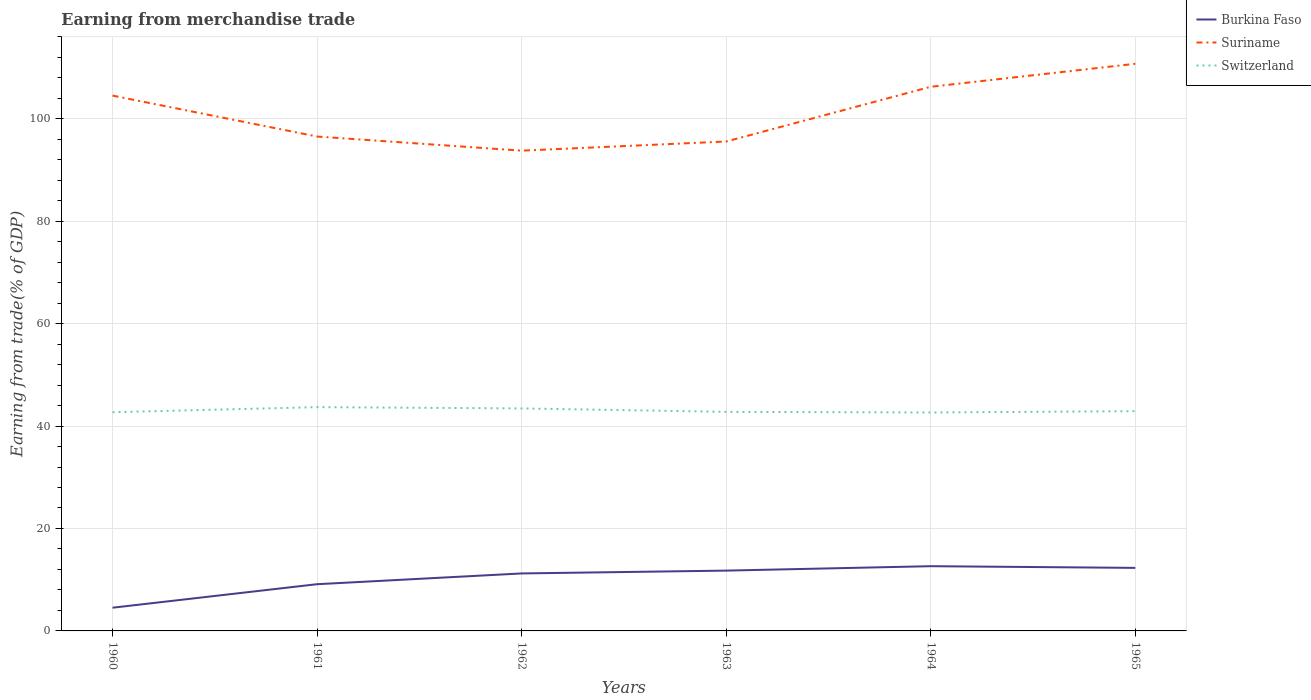Does the line corresponding to Switzerland intersect with the line corresponding to Burkina Faso?
Your response must be concise. No. Is the number of lines equal to the number of legend labels?
Your response must be concise. Yes. Across all years, what is the maximum earnings from trade in Burkina Faso?
Provide a succinct answer. 4.53. What is the total earnings from trade in Suriname in the graph?
Give a very brief answer. 8.96. What is the difference between the highest and the second highest earnings from trade in Suriname?
Ensure brevity in your answer.  16.96. What is the difference between the highest and the lowest earnings from trade in Switzerland?
Provide a succinct answer. 2. Is the earnings from trade in Switzerland strictly greater than the earnings from trade in Suriname over the years?
Your response must be concise. Yes. How many years are there in the graph?
Provide a short and direct response. 6. Does the graph contain any zero values?
Ensure brevity in your answer.  No. Does the graph contain grids?
Offer a terse response. Yes. Where does the legend appear in the graph?
Ensure brevity in your answer.  Top right. What is the title of the graph?
Provide a short and direct response. Earning from merchandise trade. Does "Morocco" appear as one of the legend labels in the graph?
Keep it short and to the point. No. What is the label or title of the X-axis?
Offer a very short reply. Years. What is the label or title of the Y-axis?
Offer a very short reply. Earning from trade(% of GDP). What is the Earning from trade(% of GDP) of Burkina Faso in 1960?
Give a very brief answer. 4.53. What is the Earning from trade(% of GDP) of Suriname in 1960?
Keep it short and to the point. 104.5. What is the Earning from trade(% of GDP) of Switzerland in 1960?
Give a very brief answer. 42.69. What is the Earning from trade(% of GDP) in Burkina Faso in 1961?
Your response must be concise. 9.12. What is the Earning from trade(% of GDP) of Suriname in 1961?
Offer a terse response. 96.51. What is the Earning from trade(% of GDP) of Switzerland in 1961?
Your response must be concise. 43.69. What is the Earning from trade(% of GDP) of Burkina Faso in 1962?
Provide a succinct answer. 11.22. What is the Earning from trade(% of GDP) of Suriname in 1962?
Provide a short and direct response. 93.76. What is the Earning from trade(% of GDP) of Switzerland in 1962?
Your answer should be compact. 43.44. What is the Earning from trade(% of GDP) of Burkina Faso in 1963?
Make the answer very short. 11.77. What is the Earning from trade(% of GDP) of Suriname in 1963?
Offer a terse response. 95.54. What is the Earning from trade(% of GDP) in Switzerland in 1963?
Ensure brevity in your answer.  42.77. What is the Earning from trade(% of GDP) in Burkina Faso in 1964?
Your answer should be compact. 12.64. What is the Earning from trade(% of GDP) of Suriname in 1964?
Offer a very short reply. 106.23. What is the Earning from trade(% of GDP) of Switzerland in 1964?
Ensure brevity in your answer.  42.64. What is the Earning from trade(% of GDP) of Burkina Faso in 1965?
Your response must be concise. 12.31. What is the Earning from trade(% of GDP) of Suriname in 1965?
Keep it short and to the point. 110.72. What is the Earning from trade(% of GDP) in Switzerland in 1965?
Your response must be concise. 42.9. Across all years, what is the maximum Earning from trade(% of GDP) of Burkina Faso?
Provide a short and direct response. 12.64. Across all years, what is the maximum Earning from trade(% of GDP) of Suriname?
Offer a very short reply. 110.72. Across all years, what is the maximum Earning from trade(% of GDP) of Switzerland?
Offer a terse response. 43.69. Across all years, what is the minimum Earning from trade(% of GDP) in Burkina Faso?
Offer a terse response. 4.53. Across all years, what is the minimum Earning from trade(% of GDP) in Suriname?
Your response must be concise. 93.76. Across all years, what is the minimum Earning from trade(% of GDP) of Switzerland?
Your response must be concise. 42.64. What is the total Earning from trade(% of GDP) in Burkina Faso in the graph?
Provide a succinct answer. 61.59. What is the total Earning from trade(% of GDP) in Suriname in the graph?
Offer a very short reply. 607.27. What is the total Earning from trade(% of GDP) in Switzerland in the graph?
Your response must be concise. 258.13. What is the difference between the Earning from trade(% of GDP) in Burkina Faso in 1960 and that in 1961?
Offer a terse response. -4.59. What is the difference between the Earning from trade(% of GDP) of Suriname in 1960 and that in 1961?
Provide a short and direct response. 7.99. What is the difference between the Earning from trade(% of GDP) of Switzerland in 1960 and that in 1961?
Provide a succinct answer. -0.99. What is the difference between the Earning from trade(% of GDP) of Burkina Faso in 1960 and that in 1962?
Make the answer very short. -6.69. What is the difference between the Earning from trade(% of GDP) of Suriname in 1960 and that in 1962?
Keep it short and to the point. 10.75. What is the difference between the Earning from trade(% of GDP) in Switzerland in 1960 and that in 1962?
Offer a very short reply. -0.74. What is the difference between the Earning from trade(% of GDP) of Burkina Faso in 1960 and that in 1963?
Your response must be concise. -7.24. What is the difference between the Earning from trade(% of GDP) in Suriname in 1960 and that in 1963?
Give a very brief answer. 8.96. What is the difference between the Earning from trade(% of GDP) of Switzerland in 1960 and that in 1963?
Your response must be concise. -0.07. What is the difference between the Earning from trade(% of GDP) of Burkina Faso in 1960 and that in 1964?
Your response must be concise. -8.1. What is the difference between the Earning from trade(% of GDP) in Suriname in 1960 and that in 1964?
Provide a succinct answer. -1.72. What is the difference between the Earning from trade(% of GDP) of Switzerland in 1960 and that in 1964?
Keep it short and to the point. 0.05. What is the difference between the Earning from trade(% of GDP) in Burkina Faso in 1960 and that in 1965?
Make the answer very short. -7.78. What is the difference between the Earning from trade(% of GDP) in Suriname in 1960 and that in 1965?
Keep it short and to the point. -6.21. What is the difference between the Earning from trade(% of GDP) in Switzerland in 1960 and that in 1965?
Offer a terse response. -0.2. What is the difference between the Earning from trade(% of GDP) of Burkina Faso in 1961 and that in 1962?
Give a very brief answer. -2.1. What is the difference between the Earning from trade(% of GDP) in Suriname in 1961 and that in 1962?
Give a very brief answer. 2.76. What is the difference between the Earning from trade(% of GDP) of Switzerland in 1961 and that in 1962?
Your response must be concise. 0.25. What is the difference between the Earning from trade(% of GDP) in Burkina Faso in 1961 and that in 1963?
Your answer should be compact. -2.65. What is the difference between the Earning from trade(% of GDP) of Suriname in 1961 and that in 1963?
Offer a terse response. 0.97. What is the difference between the Earning from trade(% of GDP) of Switzerland in 1961 and that in 1963?
Your answer should be very brief. 0.92. What is the difference between the Earning from trade(% of GDP) in Burkina Faso in 1961 and that in 1964?
Make the answer very short. -3.52. What is the difference between the Earning from trade(% of GDP) of Suriname in 1961 and that in 1964?
Offer a very short reply. -9.71. What is the difference between the Earning from trade(% of GDP) of Switzerland in 1961 and that in 1964?
Offer a terse response. 1.04. What is the difference between the Earning from trade(% of GDP) in Burkina Faso in 1961 and that in 1965?
Provide a succinct answer. -3.19. What is the difference between the Earning from trade(% of GDP) of Suriname in 1961 and that in 1965?
Make the answer very short. -14.2. What is the difference between the Earning from trade(% of GDP) in Switzerland in 1961 and that in 1965?
Your response must be concise. 0.79. What is the difference between the Earning from trade(% of GDP) of Burkina Faso in 1962 and that in 1963?
Offer a terse response. -0.55. What is the difference between the Earning from trade(% of GDP) in Suriname in 1962 and that in 1963?
Provide a succinct answer. -1.79. What is the difference between the Earning from trade(% of GDP) in Switzerland in 1962 and that in 1963?
Make the answer very short. 0.67. What is the difference between the Earning from trade(% of GDP) in Burkina Faso in 1962 and that in 1964?
Give a very brief answer. -1.41. What is the difference between the Earning from trade(% of GDP) of Suriname in 1962 and that in 1964?
Give a very brief answer. -12.47. What is the difference between the Earning from trade(% of GDP) in Switzerland in 1962 and that in 1964?
Make the answer very short. 0.79. What is the difference between the Earning from trade(% of GDP) in Burkina Faso in 1962 and that in 1965?
Provide a succinct answer. -1.09. What is the difference between the Earning from trade(% of GDP) of Suriname in 1962 and that in 1965?
Keep it short and to the point. -16.96. What is the difference between the Earning from trade(% of GDP) of Switzerland in 1962 and that in 1965?
Your answer should be very brief. 0.54. What is the difference between the Earning from trade(% of GDP) in Burkina Faso in 1963 and that in 1964?
Offer a terse response. -0.86. What is the difference between the Earning from trade(% of GDP) in Suriname in 1963 and that in 1964?
Offer a terse response. -10.68. What is the difference between the Earning from trade(% of GDP) of Switzerland in 1963 and that in 1964?
Your answer should be very brief. 0.12. What is the difference between the Earning from trade(% of GDP) of Burkina Faso in 1963 and that in 1965?
Give a very brief answer. -0.53. What is the difference between the Earning from trade(% of GDP) in Suriname in 1963 and that in 1965?
Your response must be concise. -15.17. What is the difference between the Earning from trade(% of GDP) of Switzerland in 1963 and that in 1965?
Offer a very short reply. -0.13. What is the difference between the Earning from trade(% of GDP) in Burkina Faso in 1964 and that in 1965?
Your answer should be very brief. 0.33. What is the difference between the Earning from trade(% of GDP) in Suriname in 1964 and that in 1965?
Ensure brevity in your answer.  -4.49. What is the difference between the Earning from trade(% of GDP) in Switzerland in 1964 and that in 1965?
Make the answer very short. -0.26. What is the difference between the Earning from trade(% of GDP) in Burkina Faso in 1960 and the Earning from trade(% of GDP) in Suriname in 1961?
Ensure brevity in your answer.  -91.98. What is the difference between the Earning from trade(% of GDP) of Burkina Faso in 1960 and the Earning from trade(% of GDP) of Switzerland in 1961?
Offer a terse response. -39.16. What is the difference between the Earning from trade(% of GDP) in Suriname in 1960 and the Earning from trade(% of GDP) in Switzerland in 1961?
Ensure brevity in your answer.  60.82. What is the difference between the Earning from trade(% of GDP) in Burkina Faso in 1960 and the Earning from trade(% of GDP) in Suriname in 1962?
Provide a short and direct response. -89.22. What is the difference between the Earning from trade(% of GDP) in Burkina Faso in 1960 and the Earning from trade(% of GDP) in Switzerland in 1962?
Your response must be concise. -38.91. What is the difference between the Earning from trade(% of GDP) in Suriname in 1960 and the Earning from trade(% of GDP) in Switzerland in 1962?
Make the answer very short. 61.07. What is the difference between the Earning from trade(% of GDP) in Burkina Faso in 1960 and the Earning from trade(% of GDP) in Suriname in 1963?
Keep it short and to the point. -91.01. What is the difference between the Earning from trade(% of GDP) in Burkina Faso in 1960 and the Earning from trade(% of GDP) in Switzerland in 1963?
Provide a short and direct response. -38.23. What is the difference between the Earning from trade(% of GDP) in Suriname in 1960 and the Earning from trade(% of GDP) in Switzerland in 1963?
Your answer should be very brief. 61.74. What is the difference between the Earning from trade(% of GDP) in Burkina Faso in 1960 and the Earning from trade(% of GDP) in Suriname in 1964?
Make the answer very short. -101.7. What is the difference between the Earning from trade(% of GDP) in Burkina Faso in 1960 and the Earning from trade(% of GDP) in Switzerland in 1964?
Offer a very short reply. -38.11. What is the difference between the Earning from trade(% of GDP) of Suriname in 1960 and the Earning from trade(% of GDP) of Switzerland in 1964?
Your response must be concise. 61.86. What is the difference between the Earning from trade(% of GDP) of Burkina Faso in 1960 and the Earning from trade(% of GDP) of Suriname in 1965?
Offer a terse response. -106.19. What is the difference between the Earning from trade(% of GDP) of Burkina Faso in 1960 and the Earning from trade(% of GDP) of Switzerland in 1965?
Keep it short and to the point. -38.37. What is the difference between the Earning from trade(% of GDP) in Suriname in 1960 and the Earning from trade(% of GDP) in Switzerland in 1965?
Provide a short and direct response. 61.6. What is the difference between the Earning from trade(% of GDP) of Burkina Faso in 1961 and the Earning from trade(% of GDP) of Suriname in 1962?
Keep it short and to the point. -84.64. What is the difference between the Earning from trade(% of GDP) in Burkina Faso in 1961 and the Earning from trade(% of GDP) in Switzerland in 1962?
Keep it short and to the point. -34.32. What is the difference between the Earning from trade(% of GDP) in Suriname in 1961 and the Earning from trade(% of GDP) in Switzerland in 1962?
Offer a terse response. 53.08. What is the difference between the Earning from trade(% of GDP) in Burkina Faso in 1961 and the Earning from trade(% of GDP) in Suriname in 1963?
Offer a terse response. -86.42. What is the difference between the Earning from trade(% of GDP) in Burkina Faso in 1961 and the Earning from trade(% of GDP) in Switzerland in 1963?
Ensure brevity in your answer.  -33.65. What is the difference between the Earning from trade(% of GDP) of Suriname in 1961 and the Earning from trade(% of GDP) of Switzerland in 1963?
Your answer should be very brief. 53.75. What is the difference between the Earning from trade(% of GDP) in Burkina Faso in 1961 and the Earning from trade(% of GDP) in Suriname in 1964?
Give a very brief answer. -97.11. What is the difference between the Earning from trade(% of GDP) in Burkina Faso in 1961 and the Earning from trade(% of GDP) in Switzerland in 1964?
Ensure brevity in your answer.  -33.52. What is the difference between the Earning from trade(% of GDP) of Suriname in 1961 and the Earning from trade(% of GDP) of Switzerland in 1964?
Your answer should be compact. 53.87. What is the difference between the Earning from trade(% of GDP) in Burkina Faso in 1961 and the Earning from trade(% of GDP) in Suriname in 1965?
Provide a succinct answer. -101.6. What is the difference between the Earning from trade(% of GDP) of Burkina Faso in 1961 and the Earning from trade(% of GDP) of Switzerland in 1965?
Keep it short and to the point. -33.78. What is the difference between the Earning from trade(% of GDP) in Suriname in 1961 and the Earning from trade(% of GDP) in Switzerland in 1965?
Provide a succinct answer. 53.62. What is the difference between the Earning from trade(% of GDP) in Burkina Faso in 1962 and the Earning from trade(% of GDP) in Suriname in 1963?
Provide a short and direct response. -84.32. What is the difference between the Earning from trade(% of GDP) in Burkina Faso in 1962 and the Earning from trade(% of GDP) in Switzerland in 1963?
Give a very brief answer. -31.55. What is the difference between the Earning from trade(% of GDP) of Suriname in 1962 and the Earning from trade(% of GDP) of Switzerland in 1963?
Keep it short and to the point. 50.99. What is the difference between the Earning from trade(% of GDP) of Burkina Faso in 1962 and the Earning from trade(% of GDP) of Suriname in 1964?
Provide a succinct answer. -95.01. What is the difference between the Earning from trade(% of GDP) in Burkina Faso in 1962 and the Earning from trade(% of GDP) in Switzerland in 1964?
Offer a terse response. -31.42. What is the difference between the Earning from trade(% of GDP) in Suriname in 1962 and the Earning from trade(% of GDP) in Switzerland in 1964?
Your answer should be compact. 51.11. What is the difference between the Earning from trade(% of GDP) in Burkina Faso in 1962 and the Earning from trade(% of GDP) in Suriname in 1965?
Offer a very short reply. -99.5. What is the difference between the Earning from trade(% of GDP) in Burkina Faso in 1962 and the Earning from trade(% of GDP) in Switzerland in 1965?
Your answer should be very brief. -31.68. What is the difference between the Earning from trade(% of GDP) of Suriname in 1962 and the Earning from trade(% of GDP) of Switzerland in 1965?
Your response must be concise. 50.86. What is the difference between the Earning from trade(% of GDP) of Burkina Faso in 1963 and the Earning from trade(% of GDP) of Suriname in 1964?
Your answer should be very brief. -94.46. What is the difference between the Earning from trade(% of GDP) in Burkina Faso in 1963 and the Earning from trade(% of GDP) in Switzerland in 1964?
Keep it short and to the point. -30.87. What is the difference between the Earning from trade(% of GDP) in Suriname in 1963 and the Earning from trade(% of GDP) in Switzerland in 1964?
Keep it short and to the point. 52.9. What is the difference between the Earning from trade(% of GDP) in Burkina Faso in 1963 and the Earning from trade(% of GDP) in Suriname in 1965?
Provide a short and direct response. -98.95. What is the difference between the Earning from trade(% of GDP) of Burkina Faso in 1963 and the Earning from trade(% of GDP) of Switzerland in 1965?
Give a very brief answer. -31.13. What is the difference between the Earning from trade(% of GDP) in Suriname in 1963 and the Earning from trade(% of GDP) in Switzerland in 1965?
Your answer should be compact. 52.64. What is the difference between the Earning from trade(% of GDP) in Burkina Faso in 1964 and the Earning from trade(% of GDP) in Suriname in 1965?
Offer a very short reply. -98.08. What is the difference between the Earning from trade(% of GDP) of Burkina Faso in 1964 and the Earning from trade(% of GDP) of Switzerland in 1965?
Keep it short and to the point. -30.26. What is the difference between the Earning from trade(% of GDP) in Suriname in 1964 and the Earning from trade(% of GDP) in Switzerland in 1965?
Your answer should be compact. 63.33. What is the average Earning from trade(% of GDP) in Burkina Faso per year?
Provide a short and direct response. 10.27. What is the average Earning from trade(% of GDP) of Suriname per year?
Offer a very short reply. 101.21. What is the average Earning from trade(% of GDP) in Switzerland per year?
Your response must be concise. 43.02. In the year 1960, what is the difference between the Earning from trade(% of GDP) of Burkina Faso and Earning from trade(% of GDP) of Suriname?
Your answer should be very brief. -99.97. In the year 1960, what is the difference between the Earning from trade(% of GDP) in Burkina Faso and Earning from trade(% of GDP) in Switzerland?
Offer a very short reply. -38.16. In the year 1960, what is the difference between the Earning from trade(% of GDP) in Suriname and Earning from trade(% of GDP) in Switzerland?
Your response must be concise. 61.81. In the year 1961, what is the difference between the Earning from trade(% of GDP) in Burkina Faso and Earning from trade(% of GDP) in Suriname?
Your response must be concise. -87.39. In the year 1961, what is the difference between the Earning from trade(% of GDP) of Burkina Faso and Earning from trade(% of GDP) of Switzerland?
Your answer should be compact. -34.57. In the year 1961, what is the difference between the Earning from trade(% of GDP) in Suriname and Earning from trade(% of GDP) in Switzerland?
Your answer should be compact. 52.83. In the year 1962, what is the difference between the Earning from trade(% of GDP) in Burkina Faso and Earning from trade(% of GDP) in Suriname?
Make the answer very short. -82.54. In the year 1962, what is the difference between the Earning from trade(% of GDP) of Burkina Faso and Earning from trade(% of GDP) of Switzerland?
Give a very brief answer. -32.22. In the year 1962, what is the difference between the Earning from trade(% of GDP) in Suriname and Earning from trade(% of GDP) in Switzerland?
Offer a terse response. 50.32. In the year 1963, what is the difference between the Earning from trade(% of GDP) in Burkina Faso and Earning from trade(% of GDP) in Suriname?
Your response must be concise. -83.77. In the year 1963, what is the difference between the Earning from trade(% of GDP) in Burkina Faso and Earning from trade(% of GDP) in Switzerland?
Provide a short and direct response. -30.99. In the year 1963, what is the difference between the Earning from trade(% of GDP) in Suriname and Earning from trade(% of GDP) in Switzerland?
Provide a short and direct response. 52.78. In the year 1964, what is the difference between the Earning from trade(% of GDP) in Burkina Faso and Earning from trade(% of GDP) in Suriname?
Give a very brief answer. -93.59. In the year 1964, what is the difference between the Earning from trade(% of GDP) of Burkina Faso and Earning from trade(% of GDP) of Switzerland?
Provide a short and direct response. -30.01. In the year 1964, what is the difference between the Earning from trade(% of GDP) of Suriname and Earning from trade(% of GDP) of Switzerland?
Provide a succinct answer. 63.59. In the year 1965, what is the difference between the Earning from trade(% of GDP) of Burkina Faso and Earning from trade(% of GDP) of Suriname?
Provide a short and direct response. -98.41. In the year 1965, what is the difference between the Earning from trade(% of GDP) in Burkina Faso and Earning from trade(% of GDP) in Switzerland?
Offer a very short reply. -30.59. In the year 1965, what is the difference between the Earning from trade(% of GDP) in Suriname and Earning from trade(% of GDP) in Switzerland?
Your response must be concise. 67.82. What is the ratio of the Earning from trade(% of GDP) in Burkina Faso in 1960 to that in 1961?
Your answer should be very brief. 0.5. What is the ratio of the Earning from trade(% of GDP) of Suriname in 1960 to that in 1961?
Provide a short and direct response. 1.08. What is the ratio of the Earning from trade(% of GDP) of Switzerland in 1960 to that in 1961?
Ensure brevity in your answer.  0.98. What is the ratio of the Earning from trade(% of GDP) of Burkina Faso in 1960 to that in 1962?
Make the answer very short. 0.4. What is the ratio of the Earning from trade(% of GDP) in Suriname in 1960 to that in 1962?
Your response must be concise. 1.11. What is the ratio of the Earning from trade(% of GDP) of Switzerland in 1960 to that in 1962?
Offer a very short reply. 0.98. What is the ratio of the Earning from trade(% of GDP) in Burkina Faso in 1960 to that in 1963?
Provide a short and direct response. 0.39. What is the ratio of the Earning from trade(% of GDP) in Suriname in 1960 to that in 1963?
Provide a short and direct response. 1.09. What is the ratio of the Earning from trade(% of GDP) in Switzerland in 1960 to that in 1963?
Your response must be concise. 1. What is the ratio of the Earning from trade(% of GDP) of Burkina Faso in 1960 to that in 1964?
Offer a very short reply. 0.36. What is the ratio of the Earning from trade(% of GDP) of Suriname in 1960 to that in 1964?
Make the answer very short. 0.98. What is the ratio of the Earning from trade(% of GDP) of Switzerland in 1960 to that in 1964?
Give a very brief answer. 1. What is the ratio of the Earning from trade(% of GDP) in Burkina Faso in 1960 to that in 1965?
Your answer should be compact. 0.37. What is the ratio of the Earning from trade(% of GDP) in Suriname in 1960 to that in 1965?
Your response must be concise. 0.94. What is the ratio of the Earning from trade(% of GDP) of Switzerland in 1960 to that in 1965?
Your response must be concise. 1. What is the ratio of the Earning from trade(% of GDP) in Burkina Faso in 1961 to that in 1962?
Keep it short and to the point. 0.81. What is the ratio of the Earning from trade(% of GDP) in Suriname in 1961 to that in 1962?
Ensure brevity in your answer.  1.03. What is the ratio of the Earning from trade(% of GDP) in Switzerland in 1961 to that in 1962?
Your response must be concise. 1.01. What is the ratio of the Earning from trade(% of GDP) in Burkina Faso in 1961 to that in 1963?
Provide a succinct answer. 0.77. What is the ratio of the Earning from trade(% of GDP) in Suriname in 1961 to that in 1963?
Make the answer very short. 1.01. What is the ratio of the Earning from trade(% of GDP) of Switzerland in 1961 to that in 1963?
Your response must be concise. 1.02. What is the ratio of the Earning from trade(% of GDP) in Burkina Faso in 1961 to that in 1964?
Offer a terse response. 0.72. What is the ratio of the Earning from trade(% of GDP) of Suriname in 1961 to that in 1964?
Your answer should be very brief. 0.91. What is the ratio of the Earning from trade(% of GDP) of Switzerland in 1961 to that in 1964?
Make the answer very short. 1.02. What is the ratio of the Earning from trade(% of GDP) of Burkina Faso in 1961 to that in 1965?
Provide a short and direct response. 0.74. What is the ratio of the Earning from trade(% of GDP) in Suriname in 1961 to that in 1965?
Keep it short and to the point. 0.87. What is the ratio of the Earning from trade(% of GDP) of Switzerland in 1961 to that in 1965?
Make the answer very short. 1.02. What is the ratio of the Earning from trade(% of GDP) in Burkina Faso in 1962 to that in 1963?
Your response must be concise. 0.95. What is the ratio of the Earning from trade(% of GDP) of Suriname in 1962 to that in 1963?
Provide a short and direct response. 0.98. What is the ratio of the Earning from trade(% of GDP) in Switzerland in 1962 to that in 1963?
Your response must be concise. 1.02. What is the ratio of the Earning from trade(% of GDP) of Burkina Faso in 1962 to that in 1964?
Offer a very short reply. 0.89. What is the ratio of the Earning from trade(% of GDP) in Suriname in 1962 to that in 1964?
Your response must be concise. 0.88. What is the ratio of the Earning from trade(% of GDP) in Switzerland in 1962 to that in 1964?
Offer a very short reply. 1.02. What is the ratio of the Earning from trade(% of GDP) of Burkina Faso in 1962 to that in 1965?
Ensure brevity in your answer.  0.91. What is the ratio of the Earning from trade(% of GDP) of Suriname in 1962 to that in 1965?
Ensure brevity in your answer.  0.85. What is the ratio of the Earning from trade(% of GDP) in Switzerland in 1962 to that in 1965?
Make the answer very short. 1.01. What is the ratio of the Earning from trade(% of GDP) in Burkina Faso in 1963 to that in 1964?
Your response must be concise. 0.93. What is the ratio of the Earning from trade(% of GDP) of Suriname in 1963 to that in 1964?
Your answer should be compact. 0.9. What is the ratio of the Earning from trade(% of GDP) of Burkina Faso in 1963 to that in 1965?
Provide a succinct answer. 0.96. What is the ratio of the Earning from trade(% of GDP) of Suriname in 1963 to that in 1965?
Make the answer very short. 0.86. What is the ratio of the Earning from trade(% of GDP) in Burkina Faso in 1964 to that in 1965?
Your response must be concise. 1.03. What is the ratio of the Earning from trade(% of GDP) in Suriname in 1964 to that in 1965?
Provide a short and direct response. 0.96. What is the difference between the highest and the second highest Earning from trade(% of GDP) in Burkina Faso?
Offer a terse response. 0.33. What is the difference between the highest and the second highest Earning from trade(% of GDP) of Suriname?
Offer a very short reply. 4.49. What is the difference between the highest and the second highest Earning from trade(% of GDP) of Switzerland?
Ensure brevity in your answer.  0.25. What is the difference between the highest and the lowest Earning from trade(% of GDP) in Burkina Faso?
Offer a very short reply. 8.1. What is the difference between the highest and the lowest Earning from trade(% of GDP) in Suriname?
Offer a terse response. 16.96. What is the difference between the highest and the lowest Earning from trade(% of GDP) of Switzerland?
Your answer should be very brief. 1.04. 